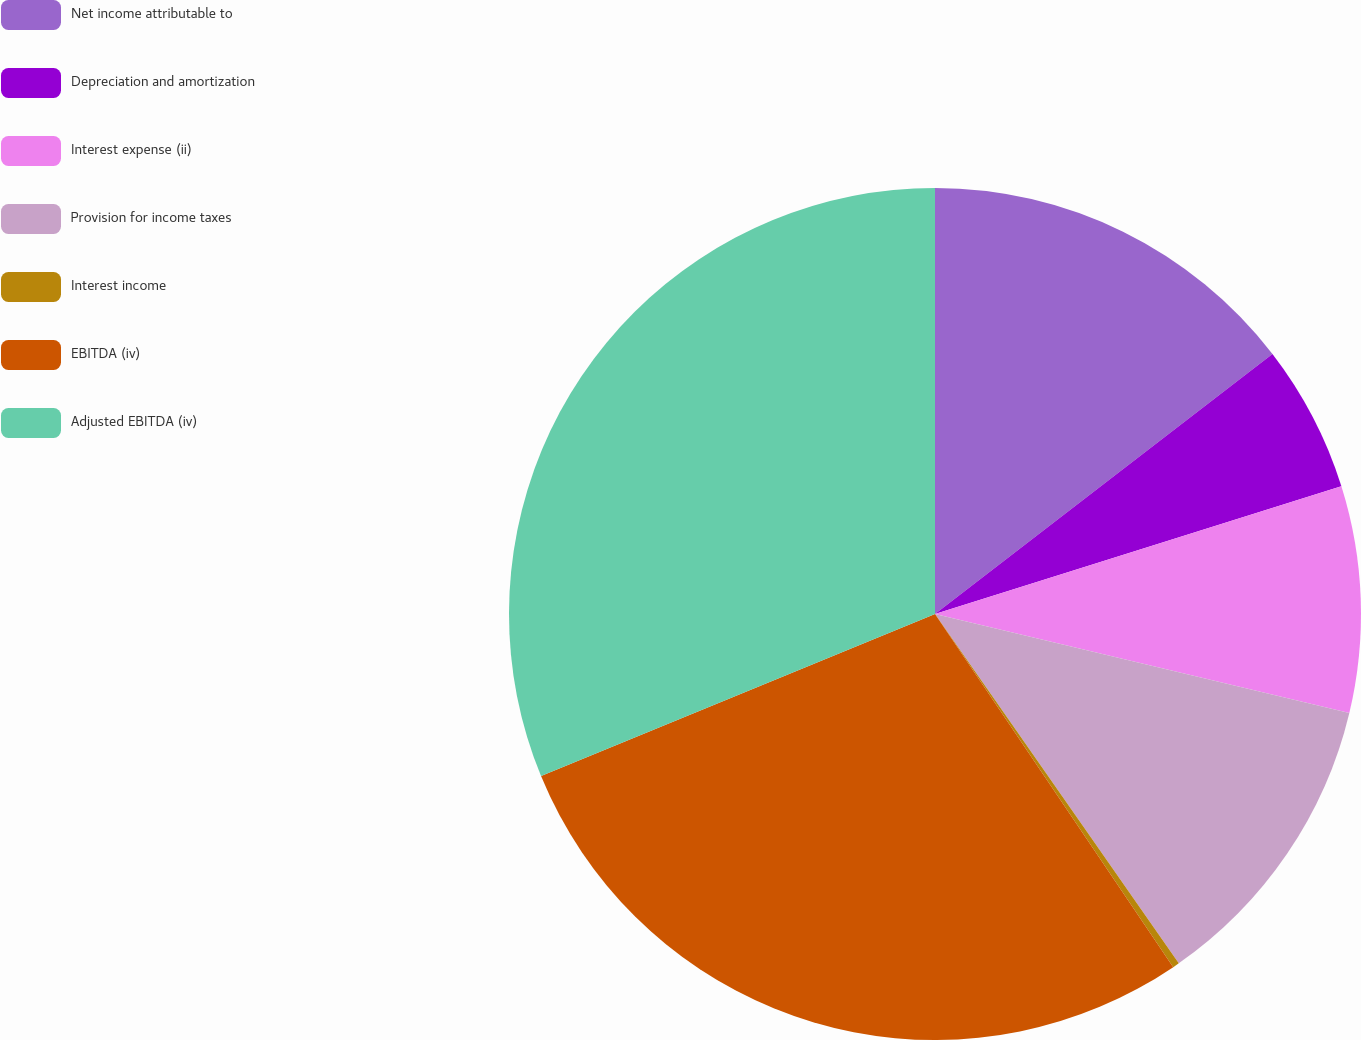Convert chart to OTSL. <chart><loc_0><loc_0><loc_500><loc_500><pie_chart><fcel>Net income attributable to<fcel>Depreciation and amortization<fcel>Interest expense (ii)<fcel>Provision for income taxes<fcel>Interest income<fcel>EBITDA (iv)<fcel>Adjusted EBITDA (iv)<nl><fcel>14.55%<fcel>5.6%<fcel>8.58%<fcel>11.57%<fcel>0.25%<fcel>28.23%<fcel>31.21%<nl></chart> 